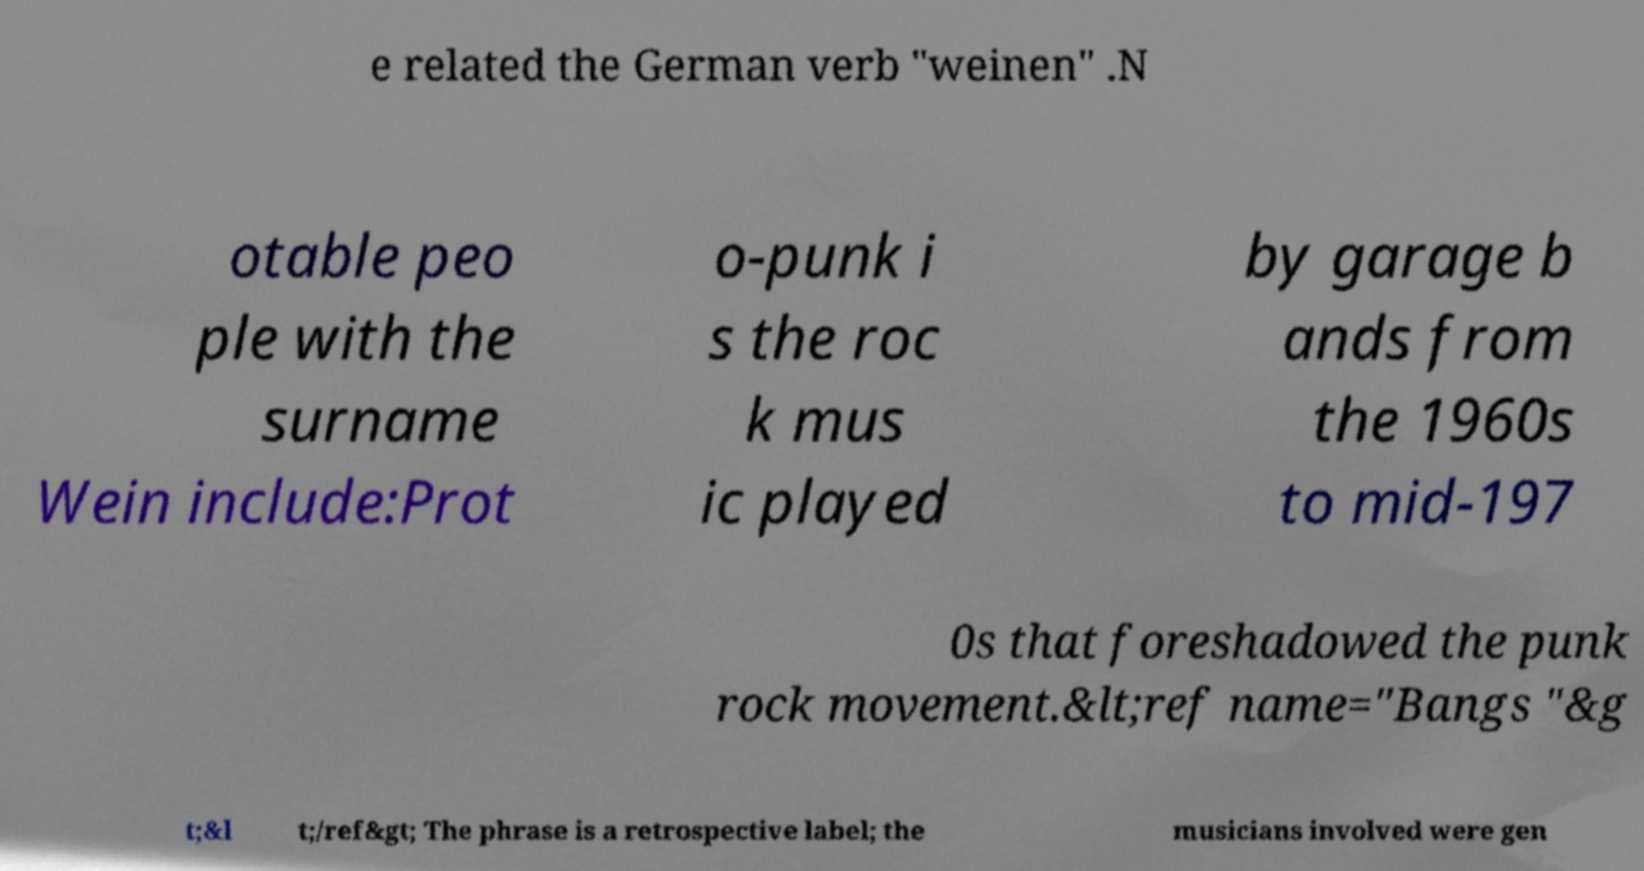Could you assist in decoding the text presented in this image and type it out clearly? e related the German verb "weinen" .N otable peo ple with the surname Wein include:Prot o-punk i s the roc k mus ic played by garage b ands from the 1960s to mid-197 0s that foreshadowed the punk rock movement.&lt;ref name="Bangs "&g t;&l t;/ref&gt; The phrase is a retrospective label; the musicians involved were gen 